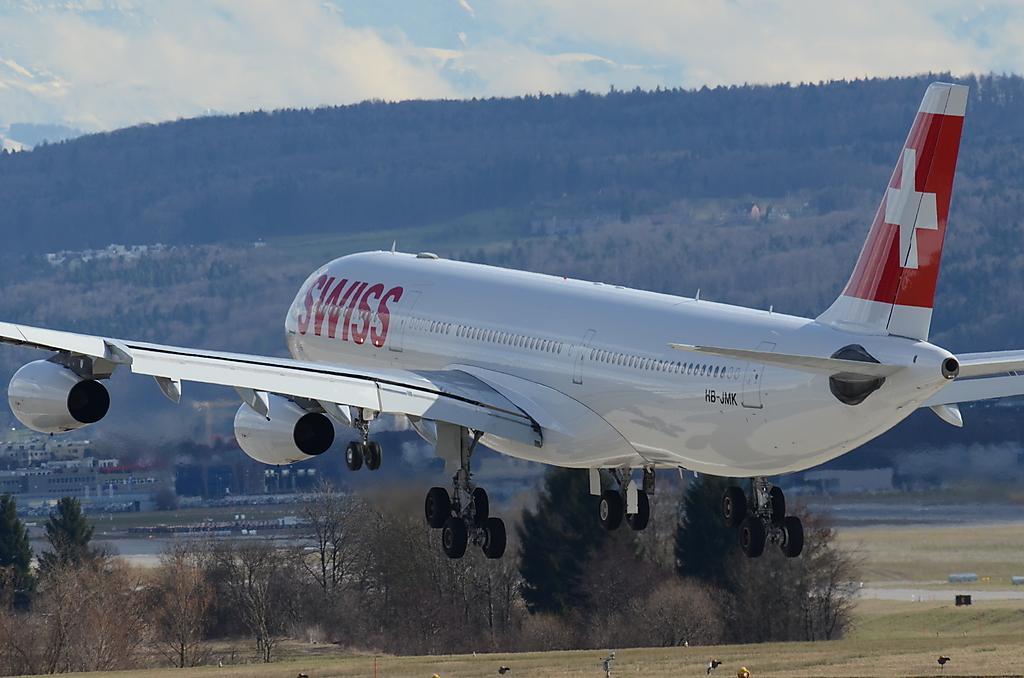Could you give a brief overview of what you see in this image? In the image we can see an airplane, white and red in color. There is a grass, trees, buildings, mountain and a cloudy sky. We can even see birds on the grass. 